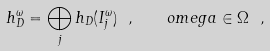Convert formula to latex. <formula><loc_0><loc_0><loc_500><loc_500>h _ { D } ^ { \omega } = \bigoplus _ { j } h _ { D } ( I _ { j } ^ { \omega } ) \ , \quad o m e g a \in \Omega \ ,</formula> 